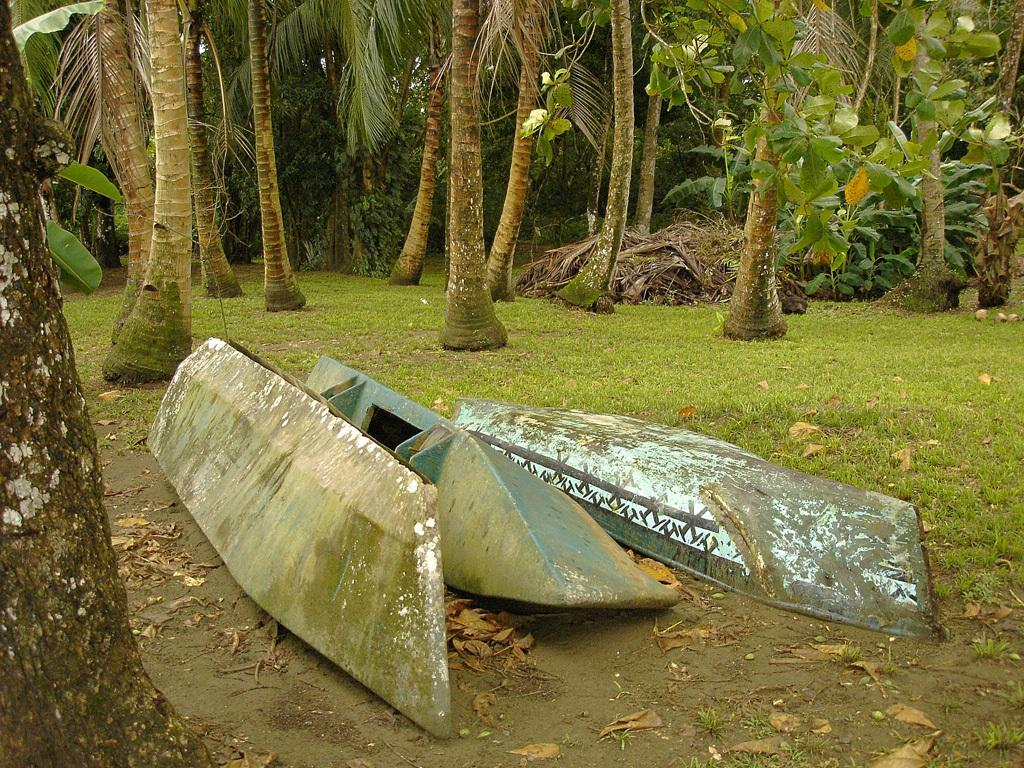What can be seen floating on the water in the image? There are boats in the image. What type of vegetation is present in the image? There are green color trees in the image. How many nails are used to hold the mitten in the image? There is no mitten or nails present in the image. What type of pencil can be seen being used by the person in the image? There is no person or pencil present in the image. 